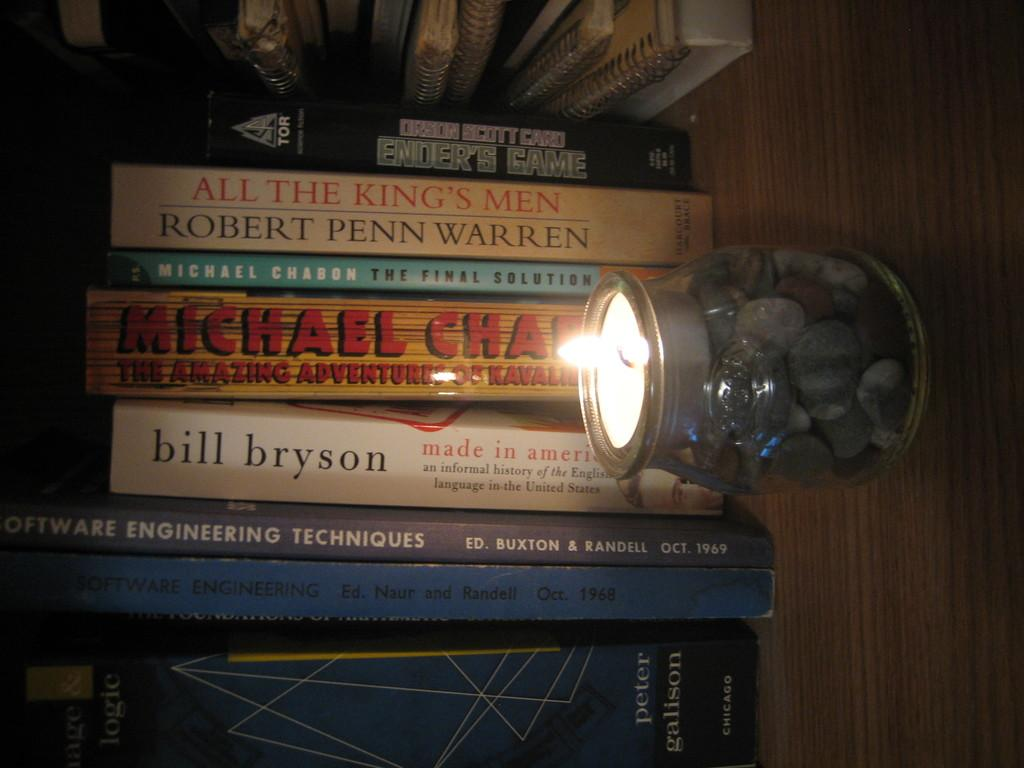<image>
Offer a succinct explanation of the picture presented. a stack of books that has one by the author 'bill bryson' on it 